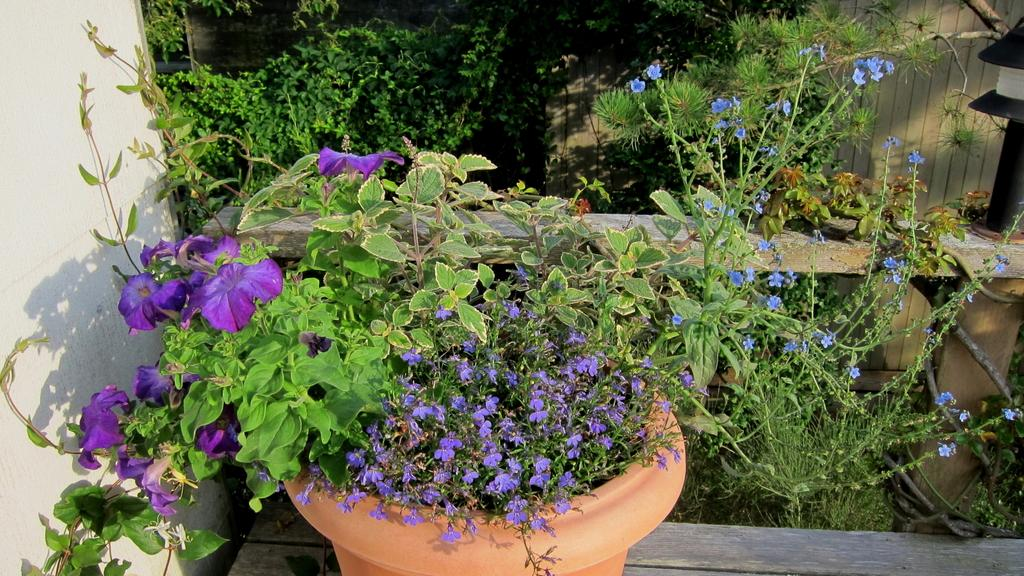What is located in the image that holds plants? There is a flower pot in the image that holds plants. Where is the flower pot placed? The flower pot is placed on a bench. What type of plants can be seen in the flower pot? There are flowers in the flower pot. What can be seen in the background of the image? There are bushes, a fence, and a wall in the background of the image. What type of meat is being grilled on the wall in the image? There is no meat or grill present in the image; it features a flower pot on a bench with flowers, and a background with bushes, a fence, and a wall. 